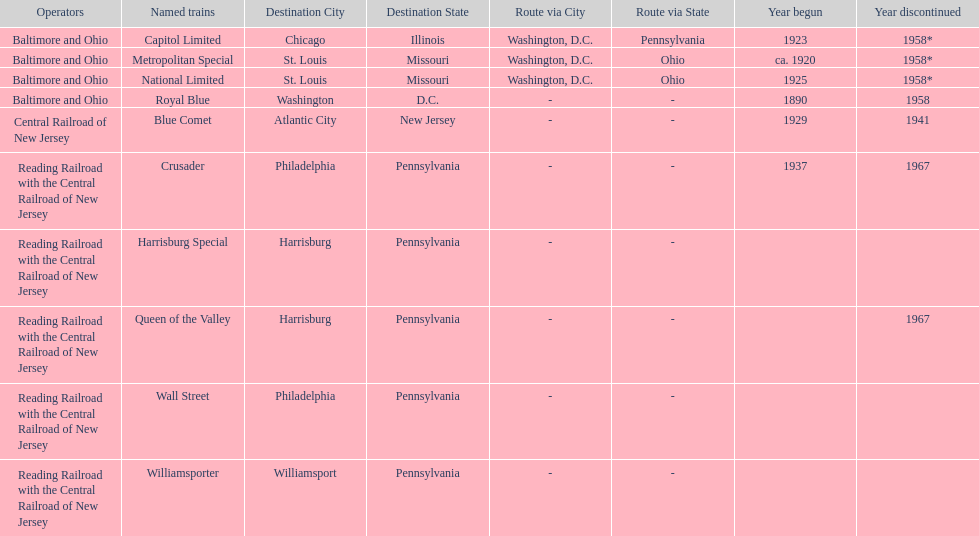What is the total of named trains? 10. 